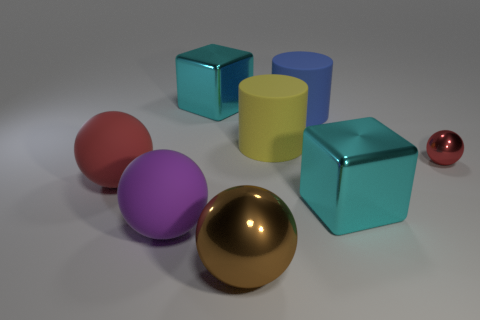What is the material of the cyan object on the left side of the blue rubber object?
Offer a very short reply. Metal. What number of other objects have the same color as the tiny metal object?
Make the answer very short. 1. There is a red object that is the same material as the big brown ball; what size is it?
Provide a short and direct response. Small. How many objects are big spheres or big purple spheres?
Provide a short and direct response. 3. There is a large metal block that is left of the brown shiny object; what is its color?
Give a very brief answer. Cyan. There is a red metal thing that is the same shape as the purple matte object; what is its size?
Provide a short and direct response. Small. What number of objects are red things in front of the red metallic sphere or large things behind the big purple matte sphere?
Make the answer very short. 5. What is the size of the sphere that is on the right side of the purple rubber object and behind the purple thing?
Keep it short and to the point. Small. There is a blue matte object; does it have the same shape as the large yellow thing that is on the left side of the blue cylinder?
Your response must be concise. Yes. How many things are big blocks that are left of the large yellow thing or large blue rubber objects?
Your answer should be very brief. 2. 